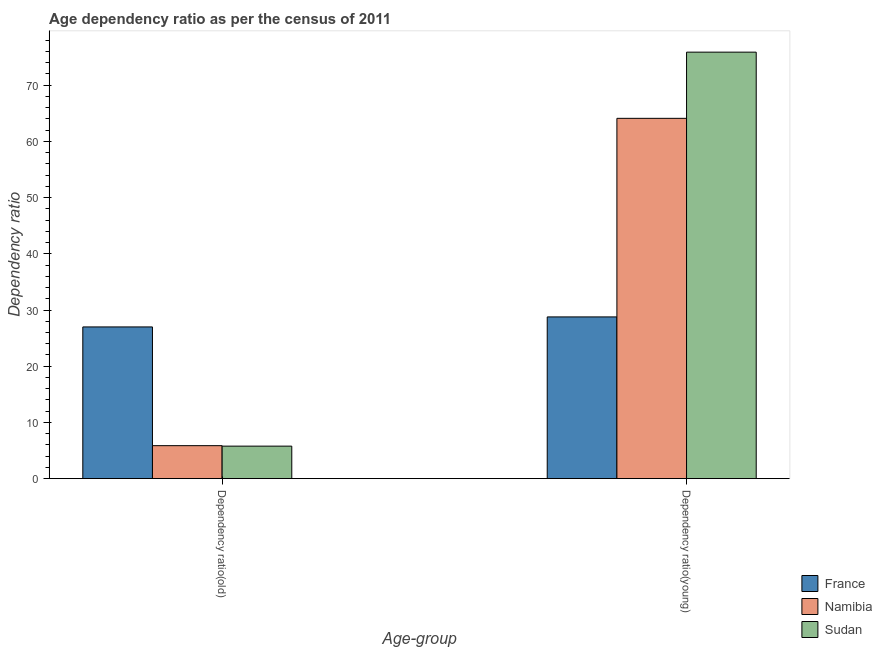Are the number of bars on each tick of the X-axis equal?
Your answer should be compact. Yes. What is the label of the 1st group of bars from the left?
Your answer should be very brief. Dependency ratio(old). What is the age dependency ratio(old) in Namibia?
Your response must be concise. 5.86. Across all countries, what is the maximum age dependency ratio(young)?
Your response must be concise. 75.88. Across all countries, what is the minimum age dependency ratio(young)?
Ensure brevity in your answer.  28.77. What is the total age dependency ratio(young) in the graph?
Keep it short and to the point. 168.76. What is the difference between the age dependency ratio(old) in France and that in Namibia?
Your answer should be compact. 21.13. What is the difference between the age dependency ratio(old) in Namibia and the age dependency ratio(young) in France?
Offer a very short reply. -22.91. What is the average age dependency ratio(old) per country?
Provide a succinct answer. 12.88. What is the difference between the age dependency ratio(young) and age dependency ratio(old) in Namibia?
Keep it short and to the point. 58.24. What is the ratio of the age dependency ratio(young) in France to that in Sudan?
Offer a very short reply. 0.38. In how many countries, is the age dependency ratio(young) greater than the average age dependency ratio(young) taken over all countries?
Your answer should be very brief. 2. What does the 3rd bar from the left in Dependency ratio(old) represents?
Provide a short and direct response. Sudan. What does the 3rd bar from the right in Dependency ratio(old) represents?
Offer a terse response. France. Are all the bars in the graph horizontal?
Provide a short and direct response. No. How many countries are there in the graph?
Your response must be concise. 3. Does the graph contain grids?
Your answer should be very brief. No. Where does the legend appear in the graph?
Your response must be concise. Bottom right. How are the legend labels stacked?
Ensure brevity in your answer.  Vertical. What is the title of the graph?
Offer a very short reply. Age dependency ratio as per the census of 2011. Does "Kenya" appear as one of the legend labels in the graph?
Your response must be concise. No. What is the label or title of the X-axis?
Make the answer very short. Age-group. What is the label or title of the Y-axis?
Provide a succinct answer. Dependency ratio. What is the Dependency ratio in France in Dependency ratio(old)?
Keep it short and to the point. 26.99. What is the Dependency ratio in Namibia in Dependency ratio(old)?
Keep it short and to the point. 5.86. What is the Dependency ratio in Sudan in Dependency ratio(old)?
Give a very brief answer. 5.78. What is the Dependency ratio of France in Dependency ratio(young)?
Your answer should be very brief. 28.77. What is the Dependency ratio of Namibia in Dependency ratio(young)?
Offer a very short reply. 64.11. What is the Dependency ratio of Sudan in Dependency ratio(young)?
Your answer should be very brief. 75.88. Across all Age-group, what is the maximum Dependency ratio of France?
Ensure brevity in your answer.  28.77. Across all Age-group, what is the maximum Dependency ratio in Namibia?
Your response must be concise. 64.11. Across all Age-group, what is the maximum Dependency ratio in Sudan?
Provide a succinct answer. 75.88. Across all Age-group, what is the minimum Dependency ratio in France?
Ensure brevity in your answer.  26.99. Across all Age-group, what is the minimum Dependency ratio in Namibia?
Your response must be concise. 5.86. Across all Age-group, what is the minimum Dependency ratio of Sudan?
Your answer should be very brief. 5.78. What is the total Dependency ratio in France in the graph?
Provide a succinct answer. 55.76. What is the total Dependency ratio in Namibia in the graph?
Your answer should be very brief. 69.97. What is the total Dependency ratio of Sudan in the graph?
Provide a short and direct response. 81.66. What is the difference between the Dependency ratio in France in Dependency ratio(old) and that in Dependency ratio(young)?
Give a very brief answer. -1.78. What is the difference between the Dependency ratio of Namibia in Dependency ratio(old) and that in Dependency ratio(young)?
Keep it short and to the point. -58.24. What is the difference between the Dependency ratio in Sudan in Dependency ratio(old) and that in Dependency ratio(young)?
Provide a succinct answer. -70.1. What is the difference between the Dependency ratio in France in Dependency ratio(old) and the Dependency ratio in Namibia in Dependency ratio(young)?
Offer a very short reply. -37.12. What is the difference between the Dependency ratio in France in Dependency ratio(old) and the Dependency ratio in Sudan in Dependency ratio(young)?
Your answer should be very brief. -48.89. What is the difference between the Dependency ratio of Namibia in Dependency ratio(old) and the Dependency ratio of Sudan in Dependency ratio(young)?
Give a very brief answer. -70.02. What is the average Dependency ratio of France per Age-group?
Your answer should be compact. 27.88. What is the average Dependency ratio of Namibia per Age-group?
Ensure brevity in your answer.  34.98. What is the average Dependency ratio in Sudan per Age-group?
Make the answer very short. 40.83. What is the difference between the Dependency ratio of France and Dependency ratio of Namibia in Dependency ratio(old)?
Your answer should be compact. 21.13. What is the difference between the Dependency ratio in France and Dependency ratio in Sudan in Dependency ratio(old)?
Offer a very short reply. 21.21. What is the difference between the Dependency ratio in Namibia and Dependency ratio in Sudan in Dependency ratio(old)?
Your answer should be compact. 0.08. What is the difference between the Dependency ratio of France and Dependency ratio of Namibia in Dependency ratio(young)?
Offer a terse response. -35.33. What is the difference between the Dependency ratio of France and Dependency ratio of Sudan in Dependency ratio(young)?
Offer a very short reply. -47.11. What is the difference between the Dependency ratio of Namibia and Dependency ratio of Sudan in Dependency ratio(young)?
Your answer should be compact. -11.78. What is the ratio of the Dependency ratio in France in Dependency ratio(old) to that in Dependency ratio(young)?
Your answer should be compact. 0.94. What is the ratio of the Dependency ratio in Namibia in Dependency ratio(old) to that in Dependency ratio(young)?
Your response must be concise. 0.09. What is the ratio of the Dependency ratio of Sudan in Dependency ratio(old) to that in Dependency ratio(young)?
Your answer should be compact. 0.08. What is the difference between the highest and the second highest Dependency ratio of France?
Make the answer very short. 1.78. What is the difference between the highest and the second highest Dependency ratio of Namibia?
Your answer should be compact. 58.24. What is the difference between the highest and the second highest Dependency ratio of Sudan?
Ensure brevity in your answer.  70.1. What is the difference between the highest and the lowest Dependency ratio of France?
Ensure brevity in your answer.  1.78. What is the difference between the highest and the lowest Dependency ratio of Namibia?
Keep it short and to the point. 58.24. What is the difference between the highest and the lowest Dependency ratio in Sudan?
Provide a short and direct response. 70.1. 